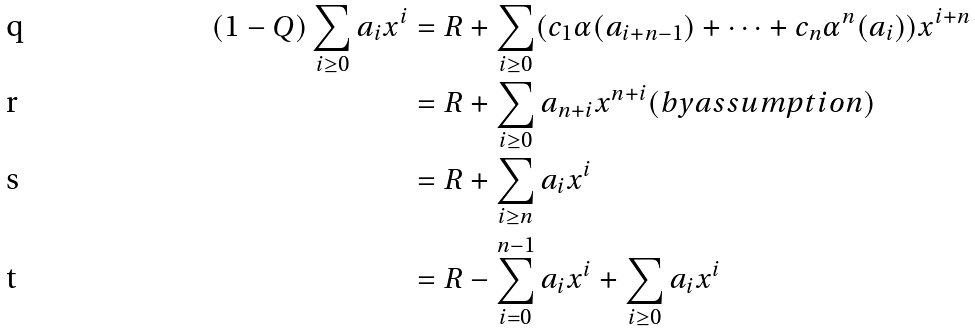Convert formula to latex. <formula><loc_0><loc_0><loc_500><loc_500>( 1 - Q ) \sum _ { i \geq 0 } a _ { i } x ^ { i } & = R + \sum _ { i \geq 0 } ( c _ { 1 } \alpha ( a _ { i + n - 1 } ) + \dots + c _ { n } \alpha ^ { n } ( a _ { i } ) ) x ^ { i + n } \\ & = R + \sum _ { i \geq 0 } a _ { n + i } x ^ { n + i } ( b y a s s u m p t i o n ) \\ & = R + \sum _ { i \geq n } a _ { i } x ^ { i } \\ & = R - \sum _ { i = 0 } ^ { n - 1 } a _ { i } x ^ { i } + \sum _ { i \geq 0 } a _ { i } x ^ { i }</formula> 